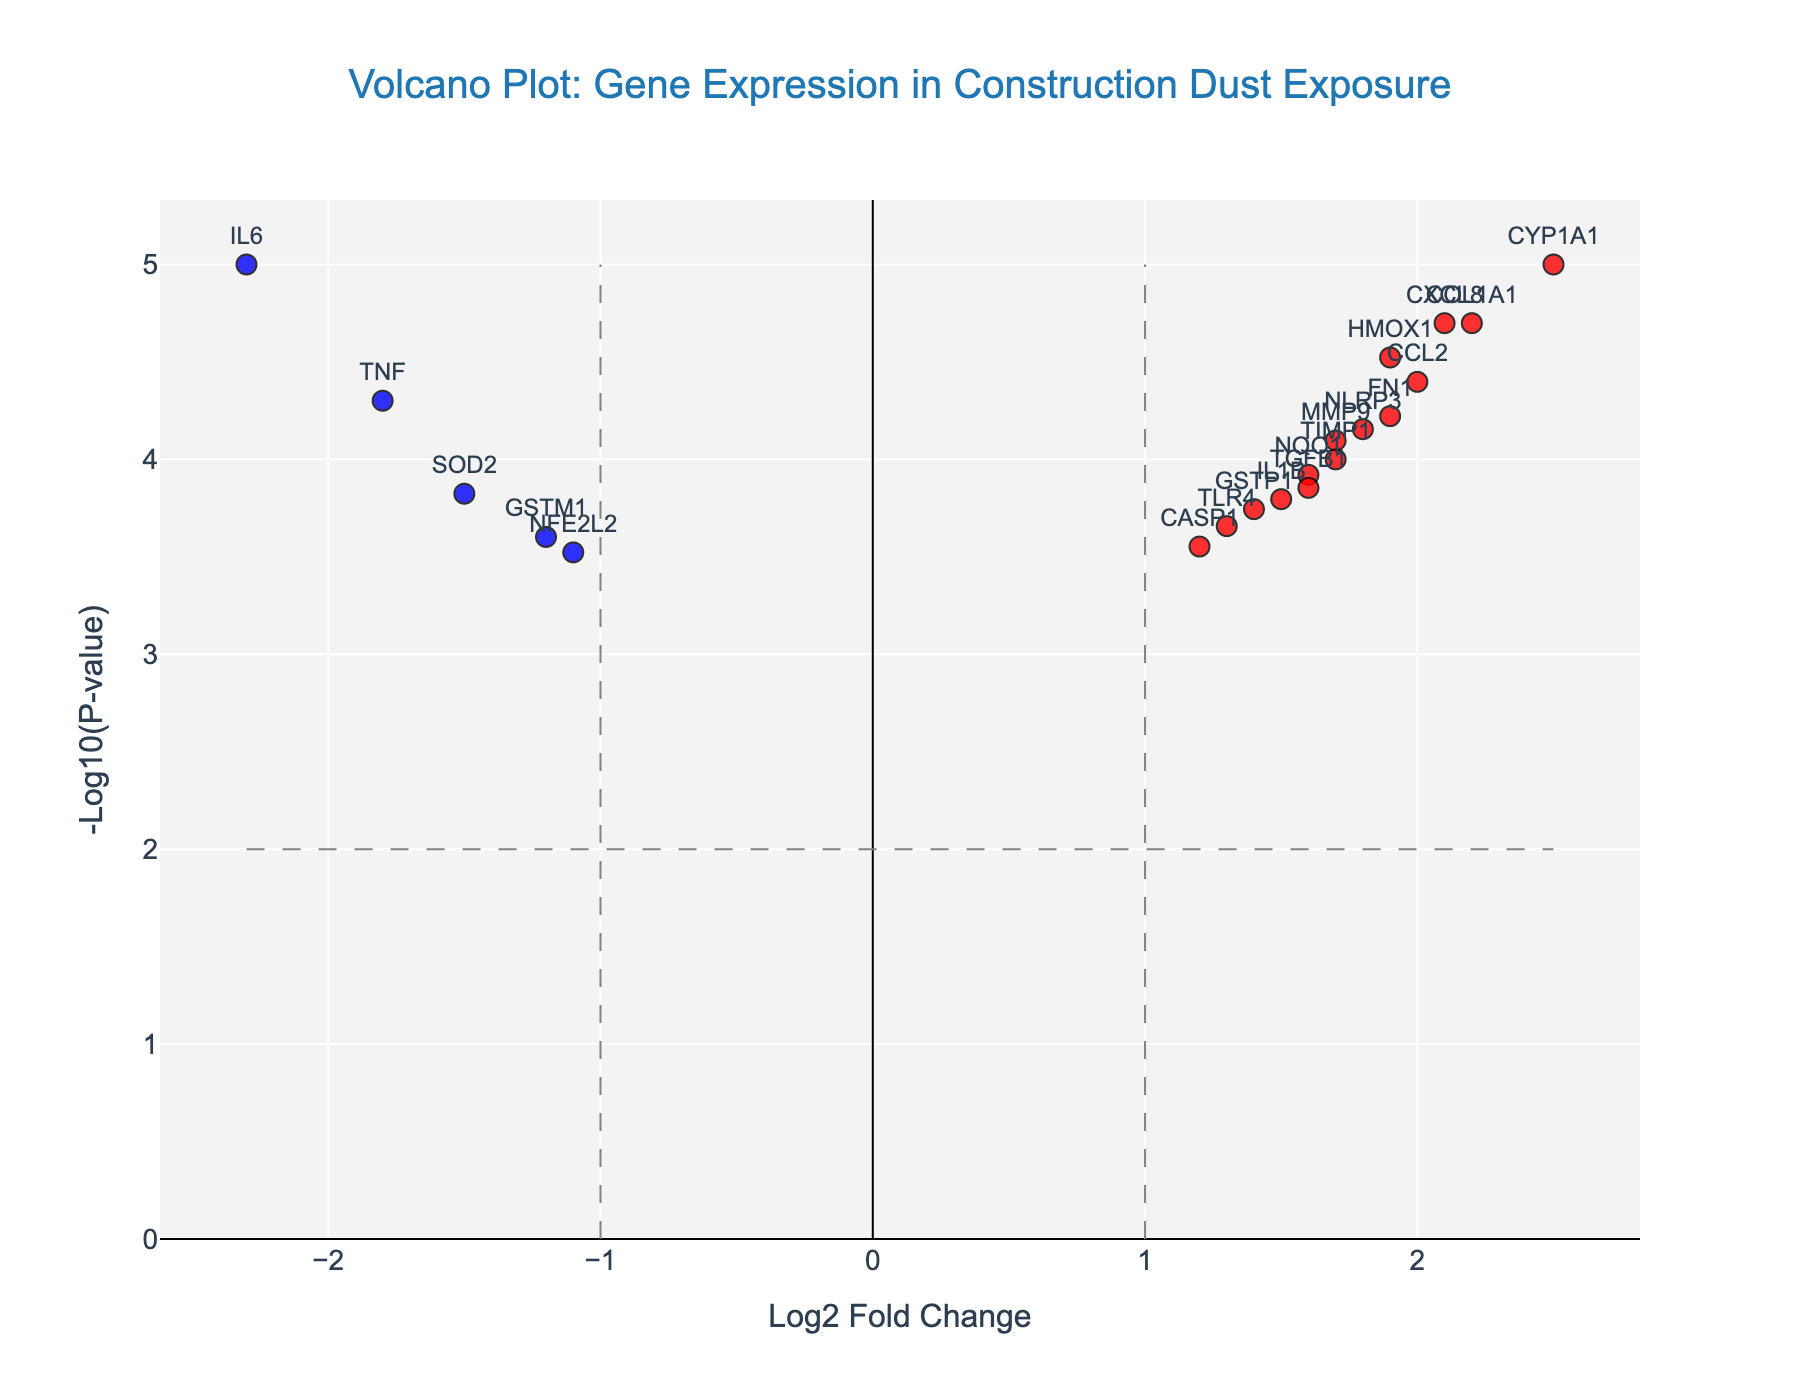How many genes have a significant upregulation (positive log2 fold change and high -log10(p-value))? First, identify the genes with a positive log2 fold change and -log10(p-value) greater than the threshold. The genes that meet these criteria are CXCL8, HMOX1, NQO1, GSTP1, CYP1A1, NLRP3, TLR4, CCL2, IL1B, TGFB1, FN1, COL1A1, TIMP1. Counting them gives a total of 13.
Answer: 13 What is the gene with the highest magnitude of downregulation (most negative log2 fold change)? To find the gene with the highest magnitude of downregulation, we look for the gene with the most negative log2 fold change value. The gene IL6 has the most negative log2 fold change of -2.3.
Answer: IL6 Which gene has the smallest p-value? The smallest p-value will be the one with the highest -log10(p-value). By examination, the gene IL6 has the smallest p-value of 0.00001.
Answer: IL6 What is the range of log2 fold change values observed in this plot? To determine the range, find the minimum and maximum log2 fold change values. The minimum is -2.3 (IL6) and the maximum is 2.5 (CYP1A1). Computing the range: 2.5 - (-2.3) = 4.8.
Answer: 4.8 How many genes are both significantly upregulated (in red) and have a p-value less than 0.0001 (i.e., -log10(p-value) greater than 4)? Identify the red genes on the plot and check for p-values less than 0.0001. The genes are CXCL8, HMOX1, and COL1A1.
Answer: 3 Which genes are located at the log2 fold change threshold lines (either exactly +1 or -1)? Examine the plot to find genes at these threshold lines. At log2 fold change of +1, there are no genes. At log2 fold change of -1, there are no genes either.
Answer: None Which gene has the highest -log10(p-value) among those with negative log2 fold change? To find this, look for the gene with the negative log2 fold change that has the highest -log10(p-value). IL6 (log2 fold change -2.3) has the highest -log10(p-value).
Answer: IL6 How many genes are significantly affected (either up or downregulated) based on both thresholds (fold change and p-value)? Count all genes that satisfy either the red or blue conditions (both up and downregulated). There are 19 such genes.
Answer: 19 